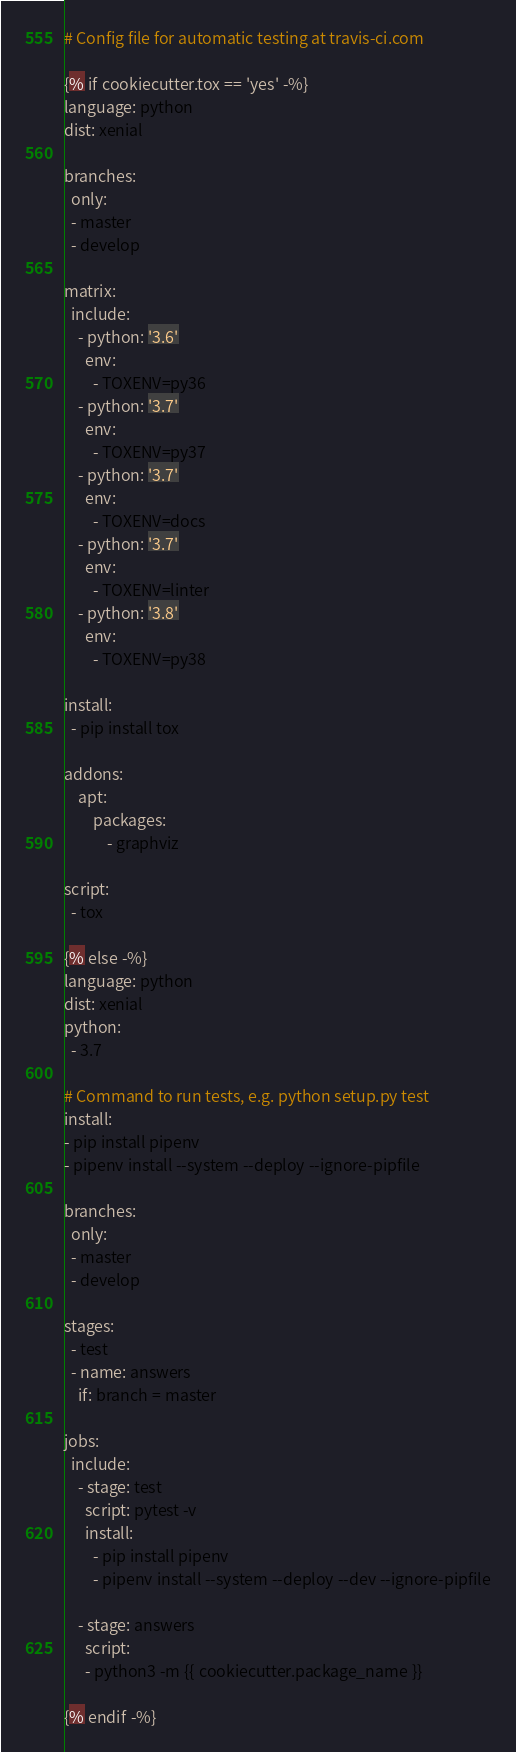Convert code to text. <code><loc_0><loc_0><loc_500><loc_500><_YAML_># Config file for automatic testing at travis-ci.com

{% if cookiecutter.tox == 'yes' -%}
language: python
dist: xenial

branches:
  only:
  - master
  - develop

matrix:
  include:
    - python: '3.6'
      env:
        - TOXENV=py36
    - python: '3.7'
      env:
        - TOXENV=py37
    - python: '3.7'
      env:
        - TOXENV=docs
    - python: '3.7'
      env:
        - TOXENV=linter
    - python: '3.8'
      env:
        - TOXENV=py38

install:
  - pip install tox

addons:
    apt:
        packages:
            - graphviz

script:
  - tox

{% else -%}
language: python
dist: xenial
python:
  - 3.7

# Command to run tests, e.g. python setup.py test
install:
- pip install pipenv
- pipenv install --system --deploy --ignore-pipfile

branches:
  only:
  - master
  - develop

stages:
  - test
  - name: answers
    if: branch = master

jobs:
  include:
    - stage: test
      script: pytest -v
      install:
        - pip install pipenv
        - pipenv install --system --deploy --dev --ignore-pipfile

    - stage: answers
      script:
      - python3 -m {{ cookiecutter.package_name }}

{% endif -%}
</code> 